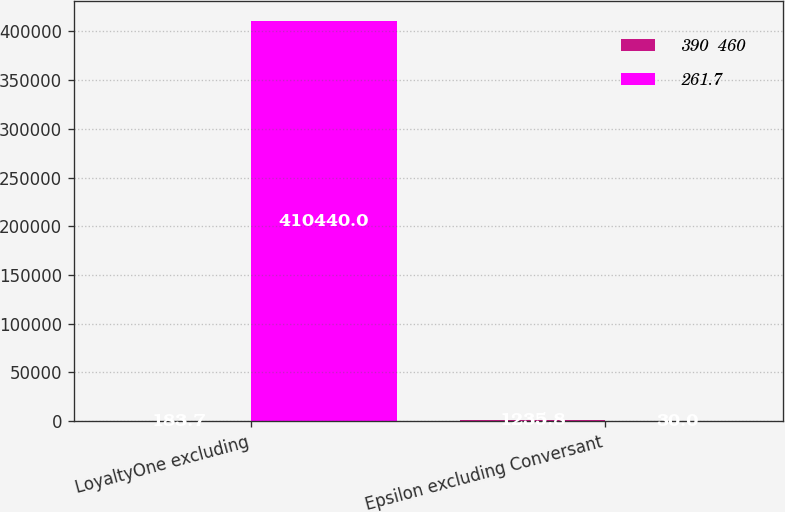Convert chart. <chart><loc_0><loc_0><loc_500><loc_500><stacked_bar_chart><ecel><fcel>LoyaltyOne excluding<fcel>Epsilon excluding Conversant<nl><fcel>390  460<fcel>183.7<fcel>1235.8<nl><fcel>261.7<fcel>410440<fcel>30<nl></chart> 